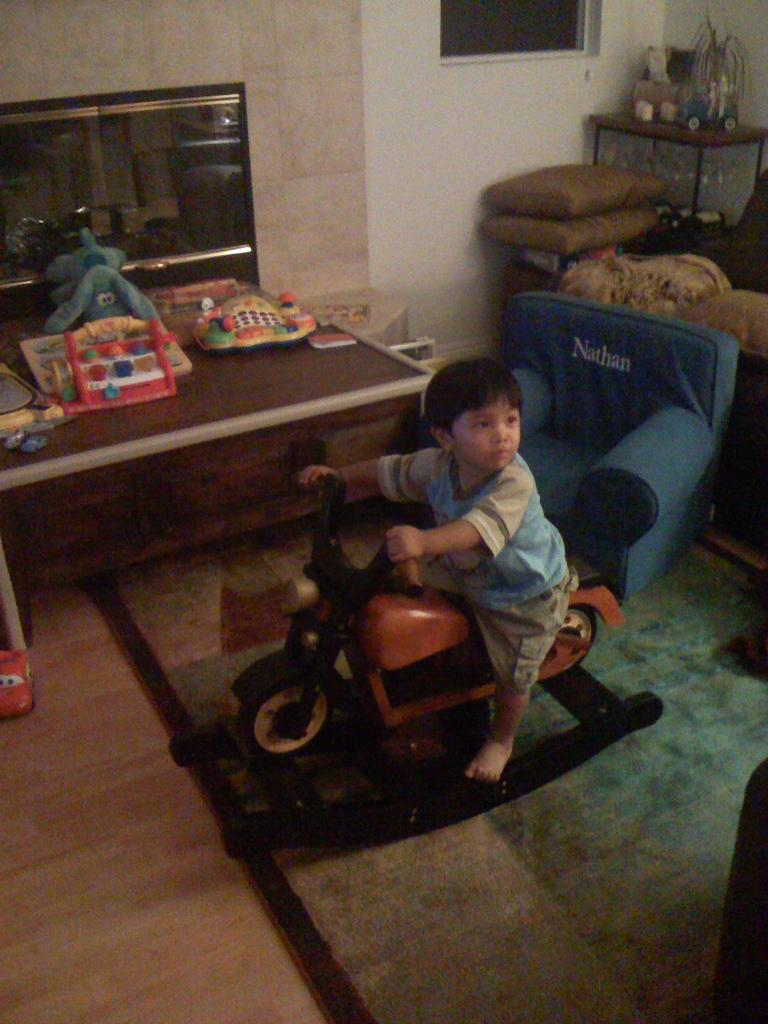Who is the main subject in the image? There is a boy in the image. What is the boy doing in the image? The boy is riding a toy. What else can be seen in the image besides the boy? There are toys on a table and a chair in the background of the image. What type of seating is visible in the background? There are cushions in the background of the image. What type of division can be seen in the image? There is no division present in the image; it is a single scene featuring a boy riding a toy and other objects in the background. 